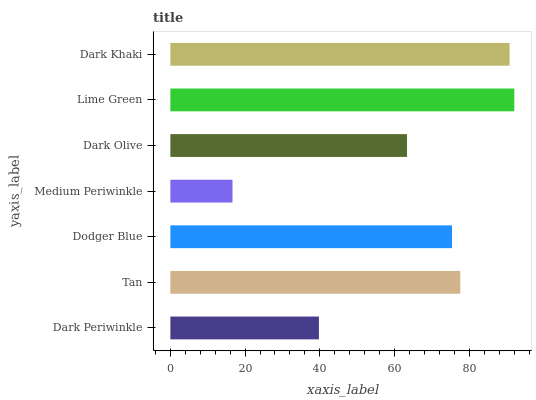Is Medium Periwinkle the minimum?
Answer yes or no. Yes. Is Lime Green the maximum?
Answer yes or no. Yes. Is Tan the minimum?
Answer yes or no. No. Is Tan the maximum?
Answer yes or no. No. Is Tan greater than Dark Periwinkle?
Answer yes or no. Yes. Is Dark Periwinkle less than Tan?
Answer yes or no. Yes. Is Dark Periwinkle greater than Tan?
Answer yes or no. No. Is Tan less than Dark Periwinkle?
Answer yes or no. No. Is Dodger Blue the high median?
Answer yes or no. Yes. Is Dodger Blue the low median?
Answer yes or no. Yes. Is Medium Periwinkle the high median?
Answer yes or no. No. Is Tan the low median?
Answer yes or no. No. 